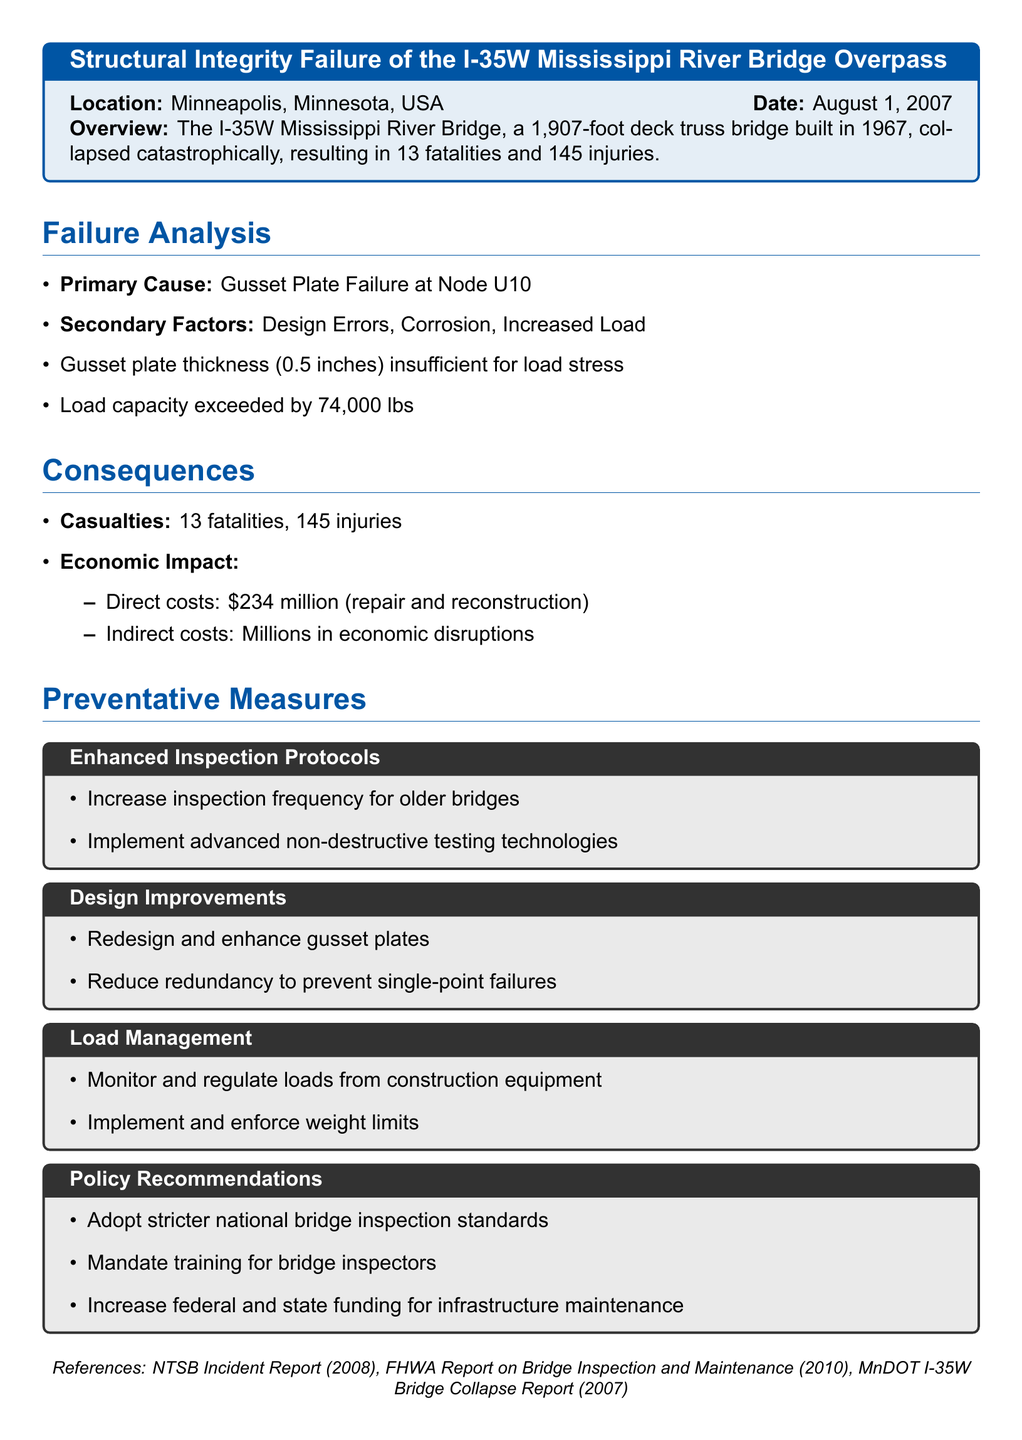What was the date of the incident? The date is mentioned in the document as August 1, 2007.
Answer: August 1, 2007 What was the primary cause of the structural failure? The primary cause is stated in the failure analysis as Gusset Plate Failure at Node U10.
Answer: Gusset Plate Failure at Node U10 How many fatalities resulted from the incident? The document specifies that there were 13 fatalities.
Answer: 13 What was the direct cost associated with the repair and reconstruction? The economic impact indicates direct costs of $234 million.
Answer: $234 million What preventative measure includes enhancing inspection frequency? The section titled Enhanced Inspection Protocols mentions increasing inspection frequency for older bridges.
Answer: Enhanced Inspection Protocols What is one design improvement recommended in the report? The report mentions redesigning and enhancing gusset plates as a design improvement.
Answer: Redesign and enhance gusset plates What is the load capacity that was exceeded? The document states the load capacity was exceeded by 74,000 lbs.
Answer: 74,000 lbs What policy recommendation involves training? The document mentions mandating training for bridge inspectors in the Policy Recommendations section.
Answer: Mandate training for bridge inspectors What city and state did the incident occur in? The location of the incident is specified as Minneapolis, Minnesota.
Answer: Minneapolis, Minnesota 